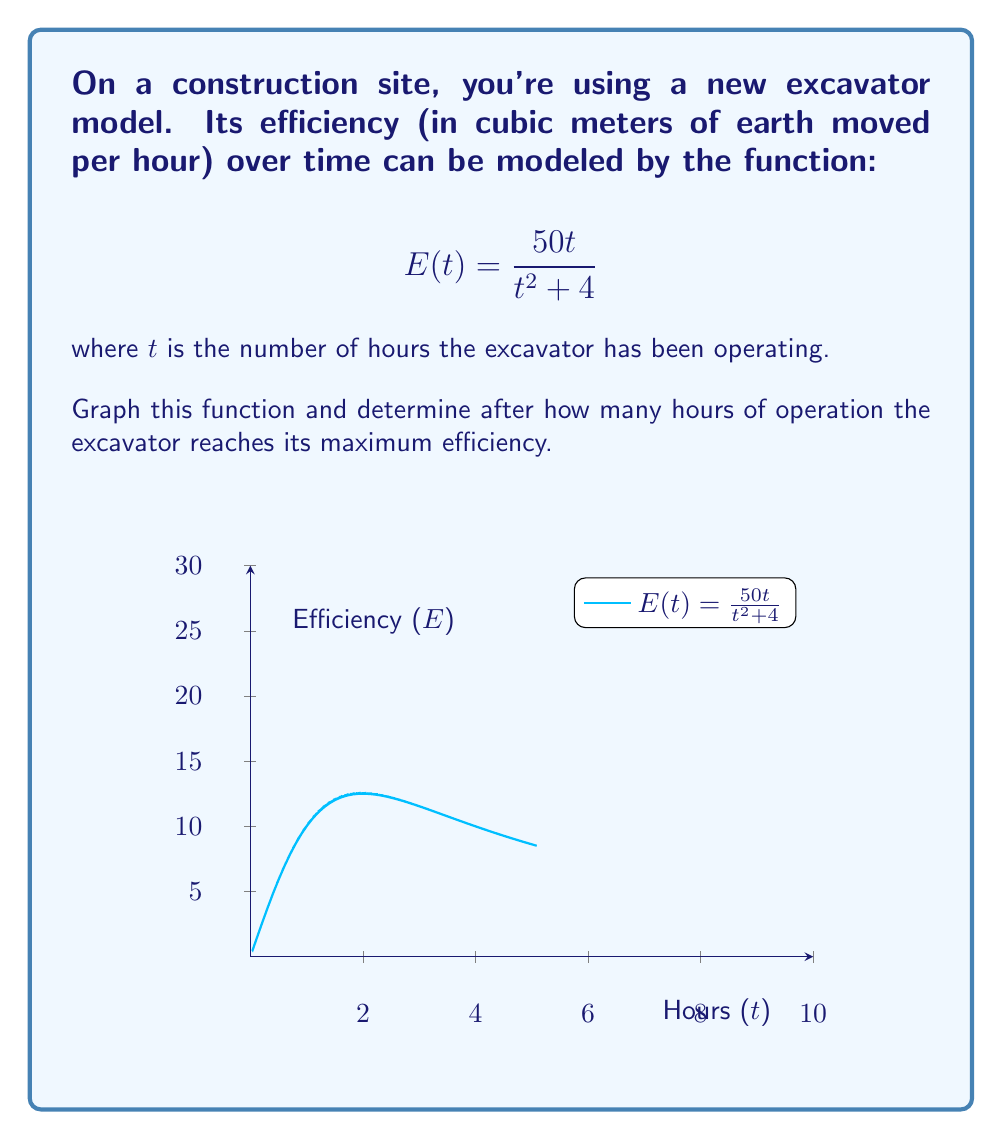Could you help me with this problem? Let's approach this step-by-step:

1) To find the maximum efficiency, we need to find the highest point on the graph. This occurs where the derivative of the function equals zero.

2) Let's calculate the derivative of $E(t)$ using the quotient rule:

   $$E'(t) = \frac{(t^2 + 4)(50) - 50t(2t)}{(t^2 + 4)^2}$$

3) Simplify:

   $$E'(t) = \frac{50t^2 + 200 - 100t^2}{(t^2 + 4)^2} = \frac{200 - 50t^2}{(t^2 + 4)^2}$$

4) Set the derivative equal to zero and solve:

   $$\frac{200 - 50t^2}{(t^2 + 4)^2} = 0$$

   $$200 - 50t^2 = 0$$
   $$200 = 50t^2$$
   $$4 = t^2$$
   $$t = 2$$ (we only consider the positive solution as time can't be negative)

5) To confirm this is a maximum, we could check the second derivative or observe the graph.

6) From the graph, we can see that the function indeed reaches its peak at $t = 2$.

Therefore, the excavator reaches its maximum efficiency after 2 hours of operation.
Answer: 2 hours 